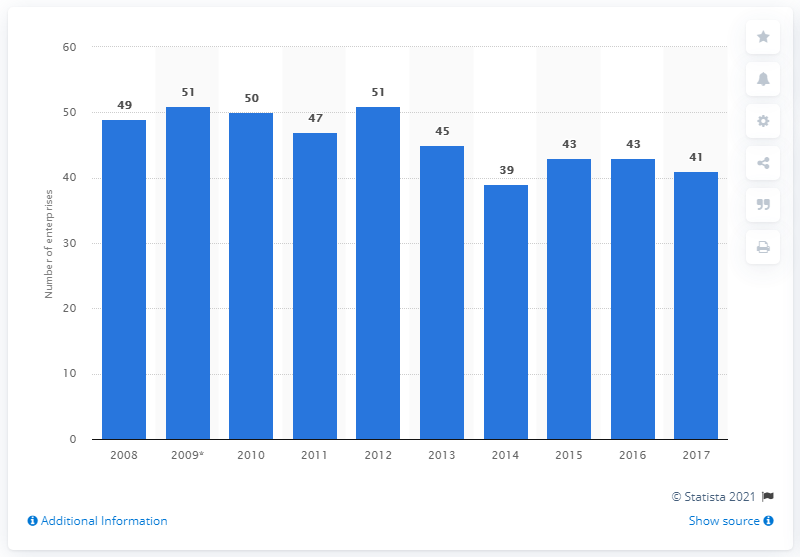Mention a couple of crucial points in this snapshot. In 2017, 41 Romanian enterprises manufactured electric domestic appliances. 